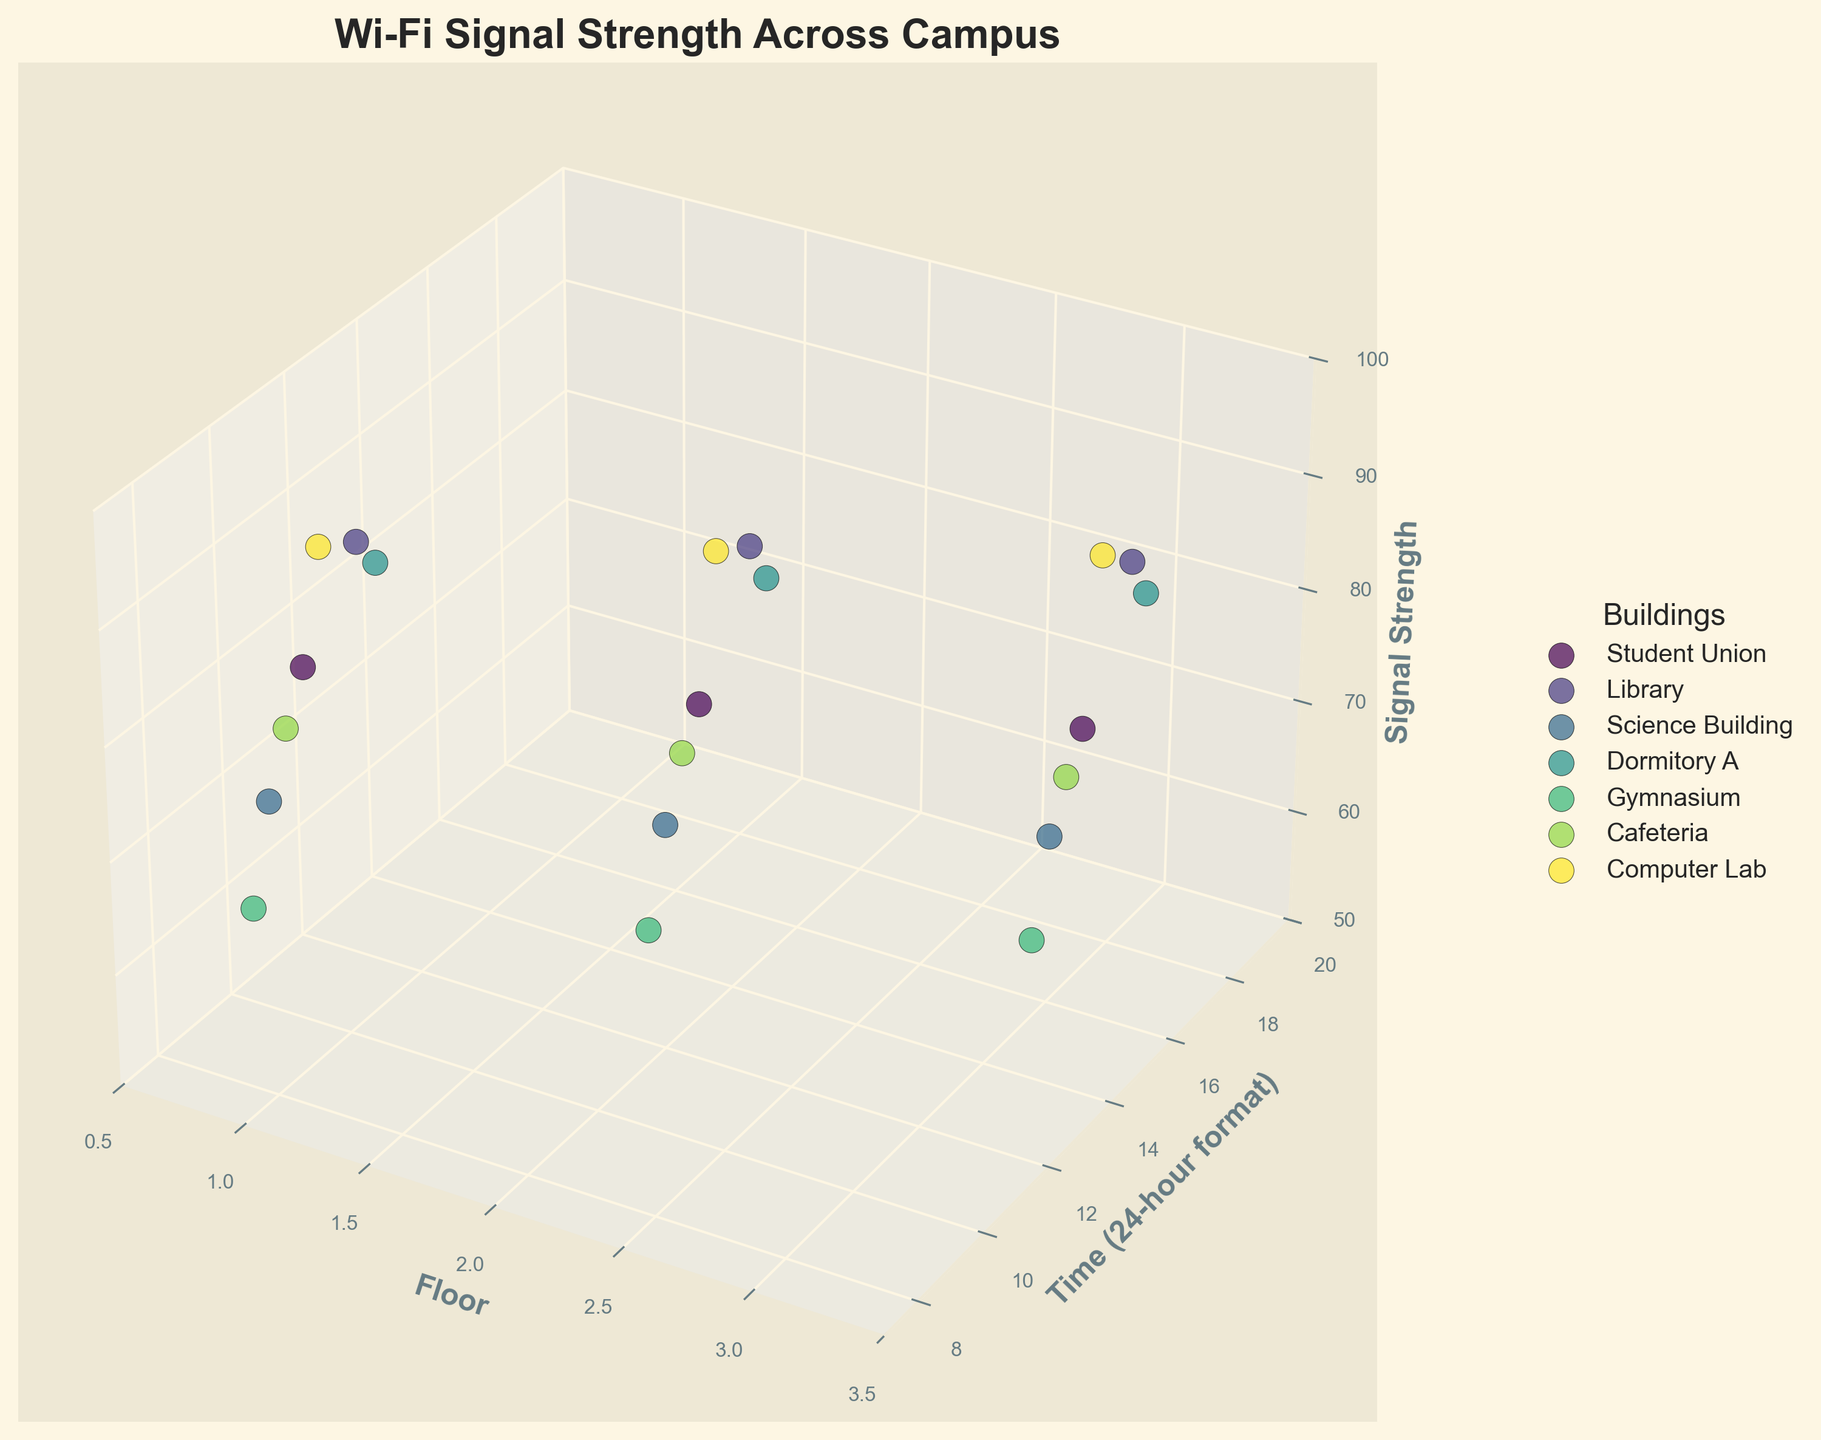What is the title of the plot? The title is usually at the top of the figure. It is a textual description that summarizes the content or purpose of the plot.
Answer: Wi-Fi Signal Strength Across Campus What are the labeled axes on the plot? To find the labeled axes, look at the text along the X, Y, and Z lines of the 3D plot.
Answer: Floor, Time (24-hour format), Signal Strength Which building has the highest Wi-Fi signal strength and what is its value? Identify the data point with the maximum Z value (Signal Strength) and look at the legend to determine the building it belongs to.
Answer: Computer Lab, 94 At what time does the Cafeteria have its highest signal strength and on which floor? Look for the highest Z value corresponding to the 'Cafeteria' in the plot and check its X (Floor) and Y (Time) position.
Answer: Floor 1 at 08:30 Which building generally has lower signal strength values based on the plot? Compare the clusters of data points for each building. The cluster with lower Z values (Signal Strength) corresponds to the building with generally lower signal strength.
Answer: Gymnasium During what time period is the Wi-Fi signal strength generally the lowest across all buildings? Look for trends in the Y (Time) axis in the plot where the Z values (Signal Strength) are relatively low across buildings.
Answer: 15:00 to 19:00 How does the signal strength vary with time in the Library? Find the Library's data points and observe the trend of the Z values (Signal Strength) against the Y (Time) axis.
Answer: It decreases from 92 at 10:30 to 83 at 18:30 On which floor does the Science Building have the weakest signal strength? Identify the data point with the lowest Z value (Signal Strength) for the Science Building and check its X (Floor) position.
Answer: Floor 3 Compare the average signal strength between the Student Union and Dormitory A. Calculate the average Z values (Signal Strength) of the data points for the Student Union and Dormitory A, then compare them. Student Union's average = (85 + 78 + 72)/3 = 78.33, Dormitory A's average = (89 + 84 + 79)/3 = 84.
Answer: Dormitory A has higher average signal strength Which building has the most consistent Wi-Fi signal strength across different floors and times? Look at the spread of Z values (Signal Strength) for each building. The building with the least variation (smallest range) in signal strength is the most consistent.
Answer: Library 